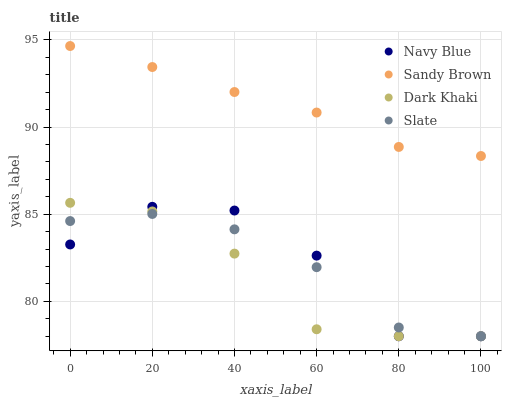Does Dark Khaki have the minimum area under the curve?
Answer yes or no. Yes. Does Sandy Brown have the maximum area under the curve?
Answer yes or no. Yes. Does Navy Blue have the minimum area under the curve?
Answer yes or no. No. Does Navy Blue have the maximum area under the curve?
Answer yes or no. No. Is Sandy Brown the smoothest?
Answer yes or no. Yes. Is Navy Blue the roughest?
Answer yes or no. Yes. Is Slate the smoothest?
Answer yes or no. No. Is Slate the roughest?
Answer yes or no. No. Does Dark Khaki have the lowest value?
Answer yes or no. Yes. Does Sandy Brown have the lowest value?
Answer yes or no. No. Does Sandy Brown have the highest value?
Answer yes or no. Yes. Does Navy Blue have the highest value?
Answer yes or no. No. Is Navy Blue less than Sandy Brown?
Answer yes or no. Yes. Is Sandy Brown greater than Slate?
Answer yes or no. Yes. Does Navy Blue intersect Slate?
Answer yes or no. Yes. Is Navy Blue less than Slate?
Answer yes or no. No. Is Navy Blue greater than Slate?
Answer yes or no. No. Does Navy Blue intersect Sandy Brown?
Answer yes or no. No. 